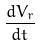Convert formula to latex. <formula><loc_0><loc_0><loc_500><loc_500>\frac { d V _ { r } } { d t }</formula> 